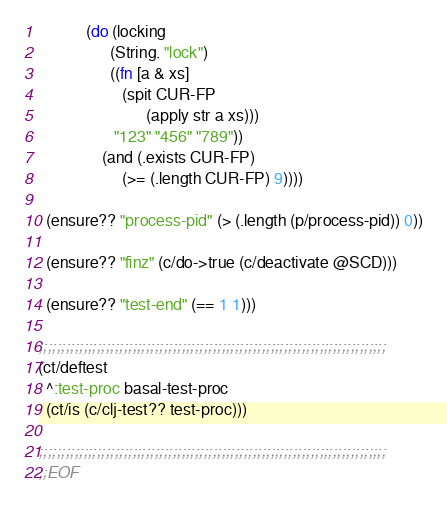<code> <loc_0><loc_0><loc_500><loc_500><_Clojure_>            (do (locking
                  (String. "lock")
                  ((fn [a & xs]
                     (spit CUR-FP
                           (apply str a xs)))
                   "123" "456" "789"))
                (and (.exists CUR-FP)
                     (>= (.length CUR-FP) 9))))

  (ensure?? "process-pid" (> (.length (p/process-pid)) 0))

  (ensure?? "finz" (c/do->true (c/deactivate @SCD)))

  (ensure?? "test-end" (== 1 1)))

;;;;;;;;;;;;;;;;;;;;;;;;;;;;;;;;;;;;;;;;;;;;;;;;;;;;;;;;;;;;;;;;;;;;;;;;;;;;;;
(ct/deftest
  ^:test-proc basal-test-proc
  (ct/is (c/clj-test?? test-proc)))

;;;;;;;;;;;;;;;;;;;;;;;;;;;;;;;;;;;;;;;;;;;;;;;;;;;;;;;;;;;;;;;;;;;;;;;;;;;;;;
;;EOF


</code> 